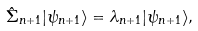<formula> <loc_0><loc_0><loc_500><loc_500>\hat { \Sigma } _ { n + 1 } | \psi _ { n + 1 } \rangle = \lambda _ { n + 1 } | \psi _ { n + 1 } \rangle ,</formula> 